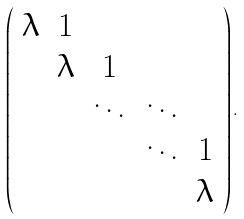Convert formula to latex. <formula><loc_0><loc_0><loc_500><loc_500>\left ( \begin{array} { c c c c c c } \lambda & 1 & & & \\ & \lambda & 1 & \\ & & \ddots & \ddots & \\ & & & \ddots & 1 \\ & & & & \lambda \end{array} \right ) .</formula> 